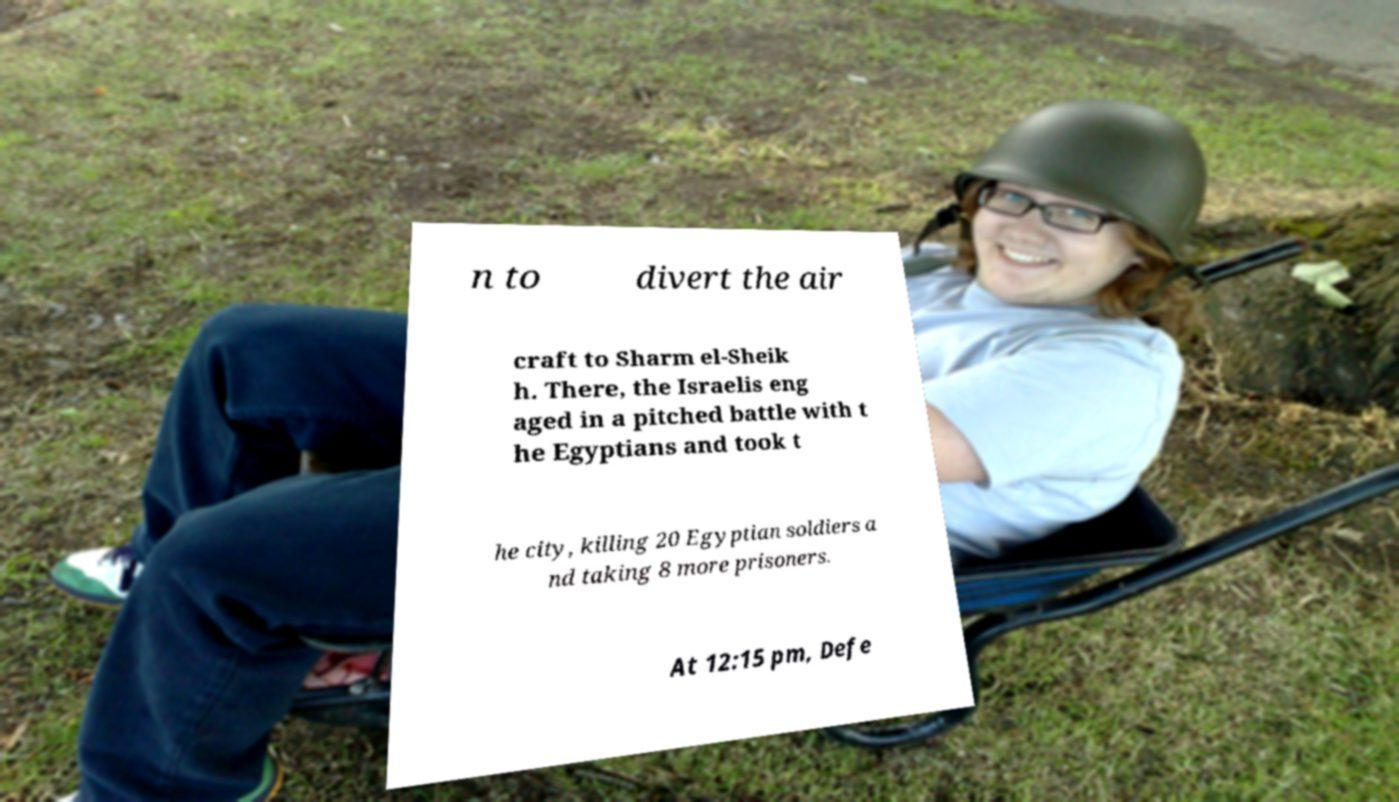Could you extract and type out the text from this image? n to divert the air craft to Sharm el-Sheik h. There, the Israelis eng aged in a pitched battle with t he Egyptians and took t he city, killing 20 Egyptian soldiers a nd taking 8 more prisoners. At 12:15 pm, Defe 